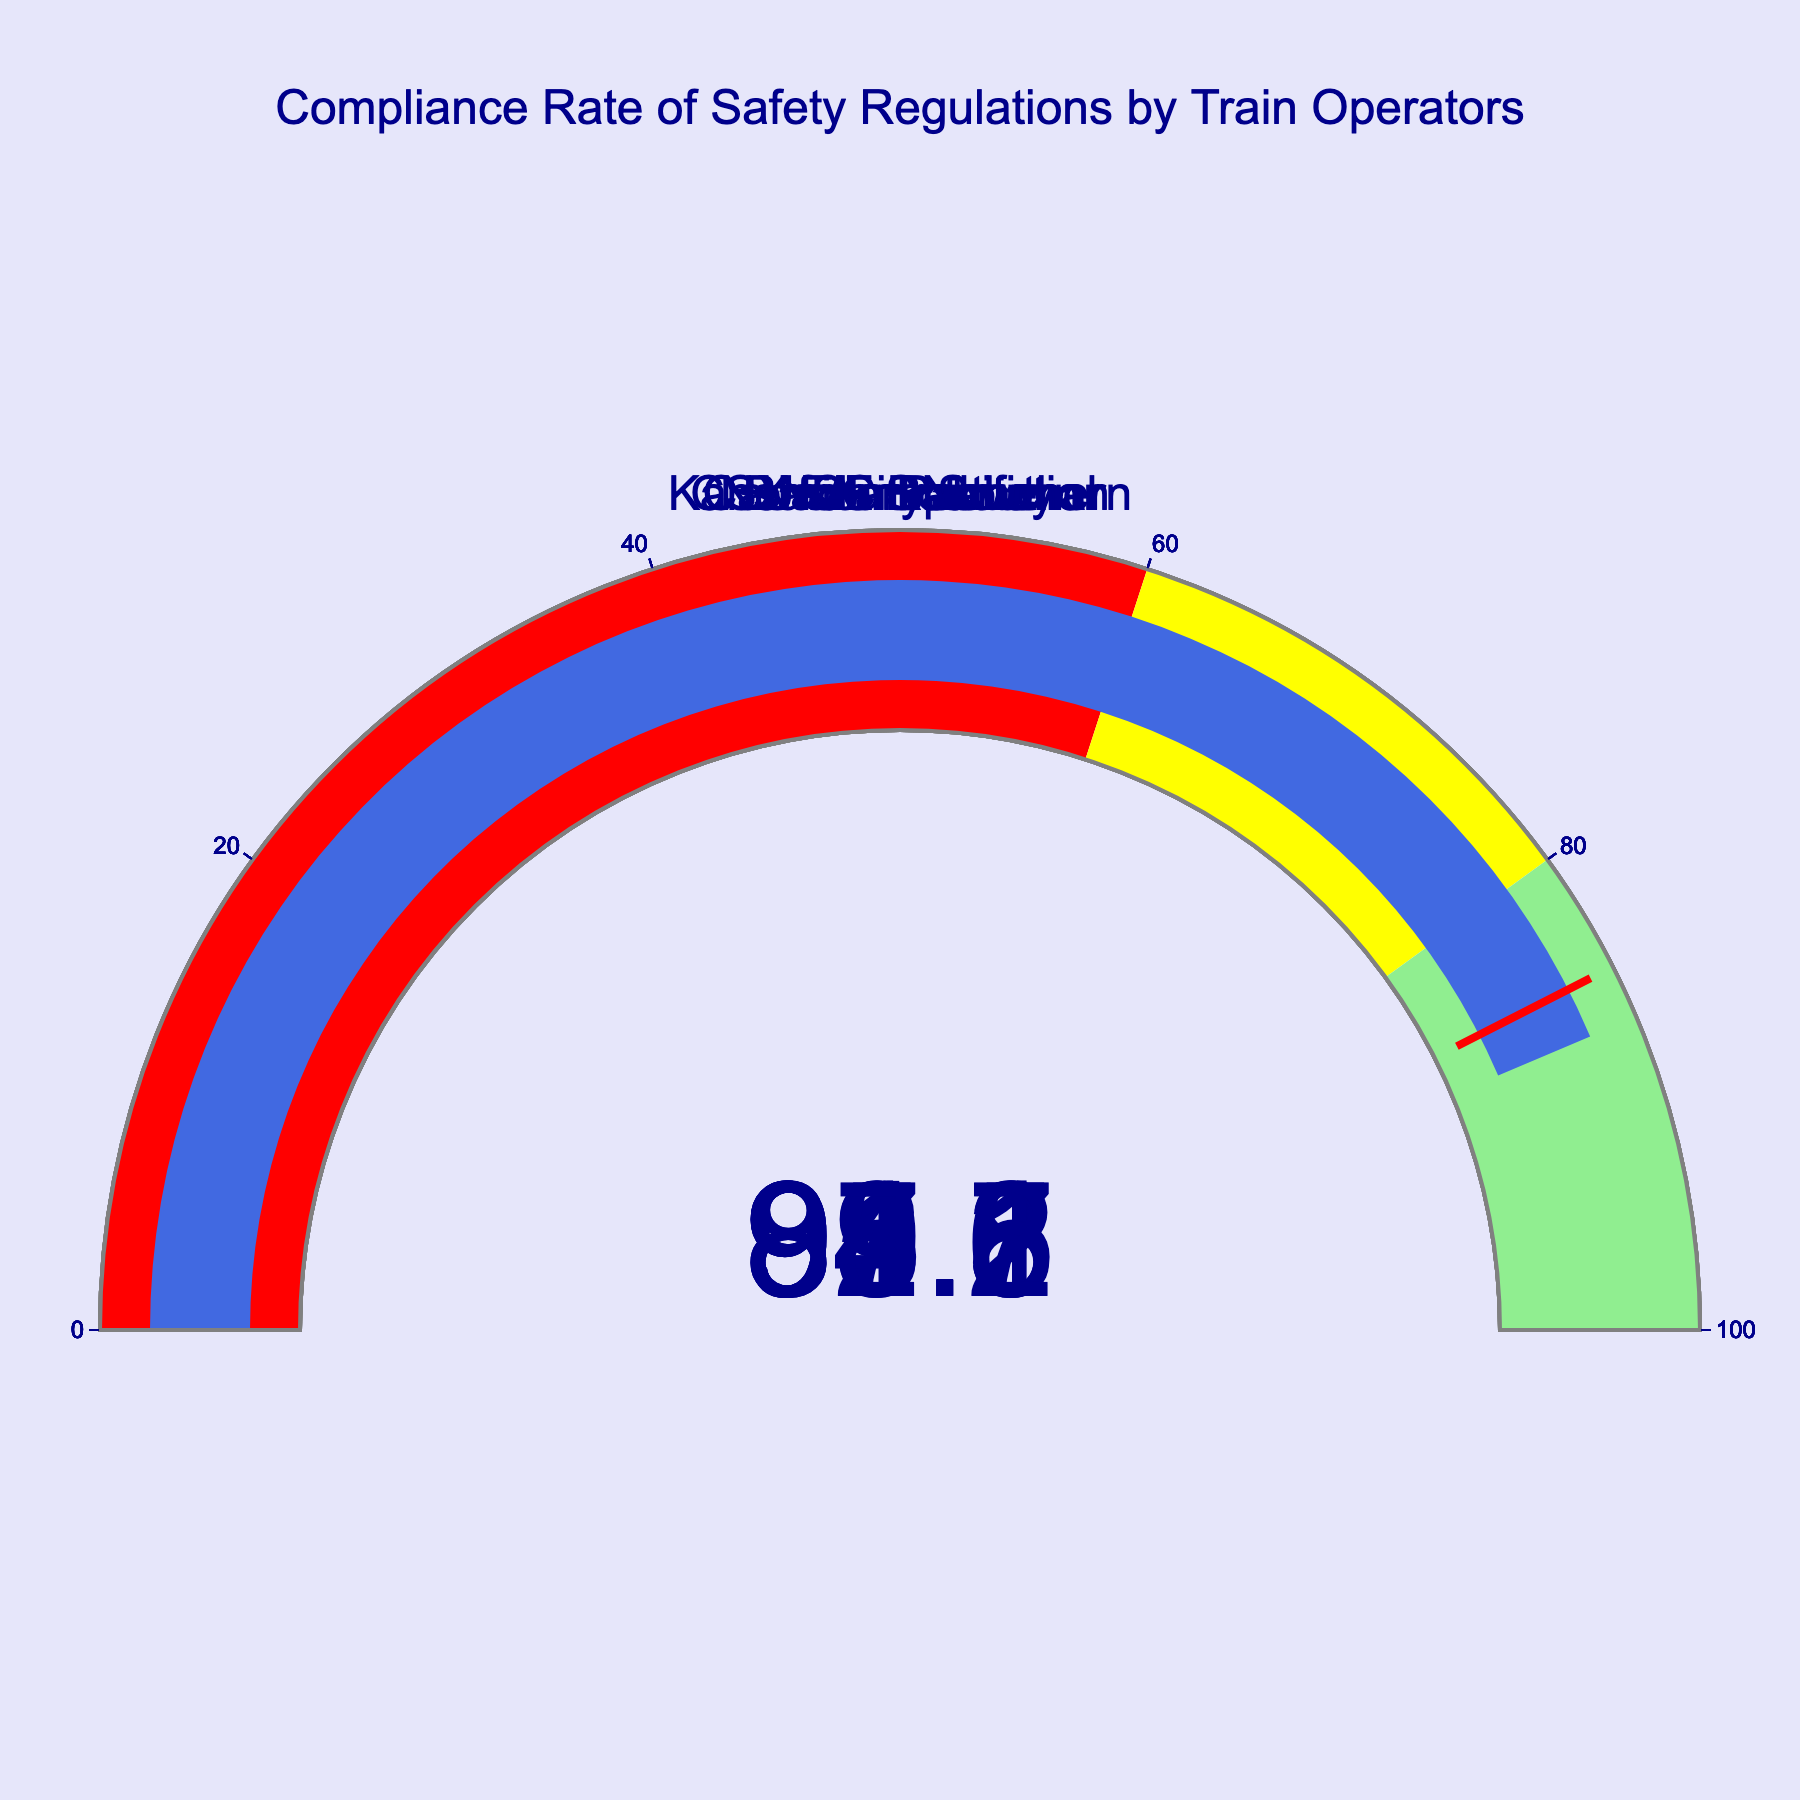What is the compliance rate for Amtrak? Look at the gauge chart labeled "Amtrak" and note the number displayed on the gauge.
Answer: 95.6 Which train operator has the lowest compliance rate? Compare the values displayed on all the gauge charts and identify the smallest number. The lowest compliance rate is for Kansas City Southern with a value of 87.2.
Answer: Kansas City Southern What is the average compliance rate of all train operators? Add up all the compliance rates and divide by the number of train operators. The rates are 92.5, 89.7, 94.3, 88.1, 91.8, 95.6, and 87.2. Sum them to get 639.2. Divide by 7 to get the average: 639.2 / 7 = 91.31.
Answer: 91.31 How many train operators have a compliance rate above 90%? Identify and count the gauges with numbers above 90. The operators are Union Pacific, CSX Transportation, Canadian National, and Amtrak. So, there are 4 in total.
Answer: 4 Which train operators fall in the "red" zone (0-60) on their gauge? Check all the gauges and see which fall within the 0-60 range. Since none of the displayed values are within this range, the answer is none.
Answer: None What is the range of compliance rates among the train operators? To find the range, subtract the lowest compliance rate from the highest. The highest is Amtrak with 95.6 and the lowest is Kansas City Southern with 87.2. So, the range is 95.6 - 87.2 = 8.4.
Answer: 8.4 Is the compliance rate of Norfolk Southern less than that of BNSF Railway? Compare the values on the gauges for Norfolk Southern (88.1) and BNSF Railway (89.7). Since 88.1 is less than 89.7, the answer is yes.
Answer: Yes Which train operators fall in the "yellow" zone (60-80) on their gauge? Check all the gauges and see which fall within the 60-80 range. Since none of the displayed values are within this range, the answer is none.
Answer: None Which train company has the highest compliance rate? Compare the values displayed on all the gauge charts and identify the largest number. The highest compliance rate is for Amtrak with a value of 95.6.
Answer: Amtrak 